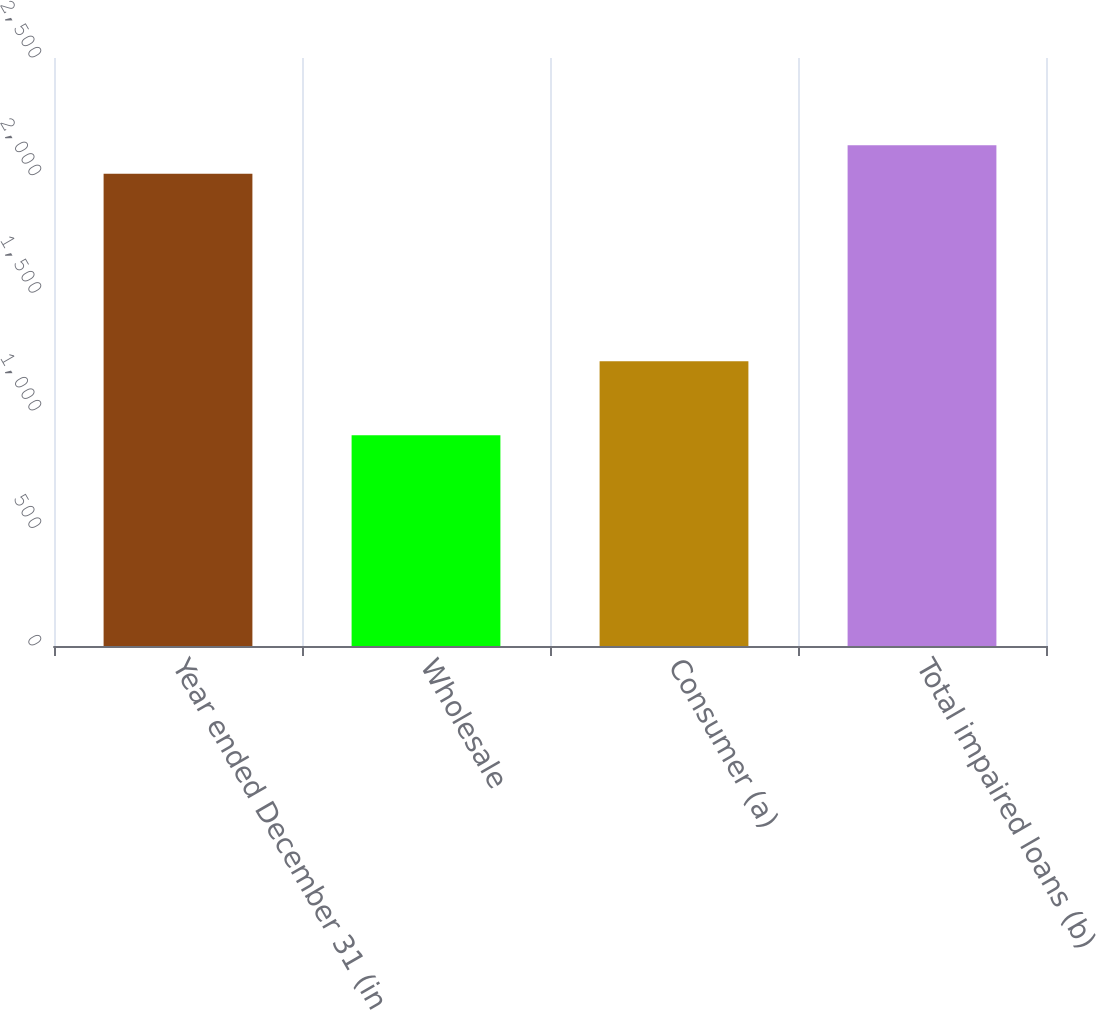<chart> <loc_0><loc_0><loc_500><loc_500><bar_chart><fcel>Year ended December 31 (in<fcel>Wholesale<fcel>Consumer (a)<fcel>Total impaired loans (b)<nl><fcel>2008<fcel>896<fcel>1211<fcel>2129.1<nl></chart> 